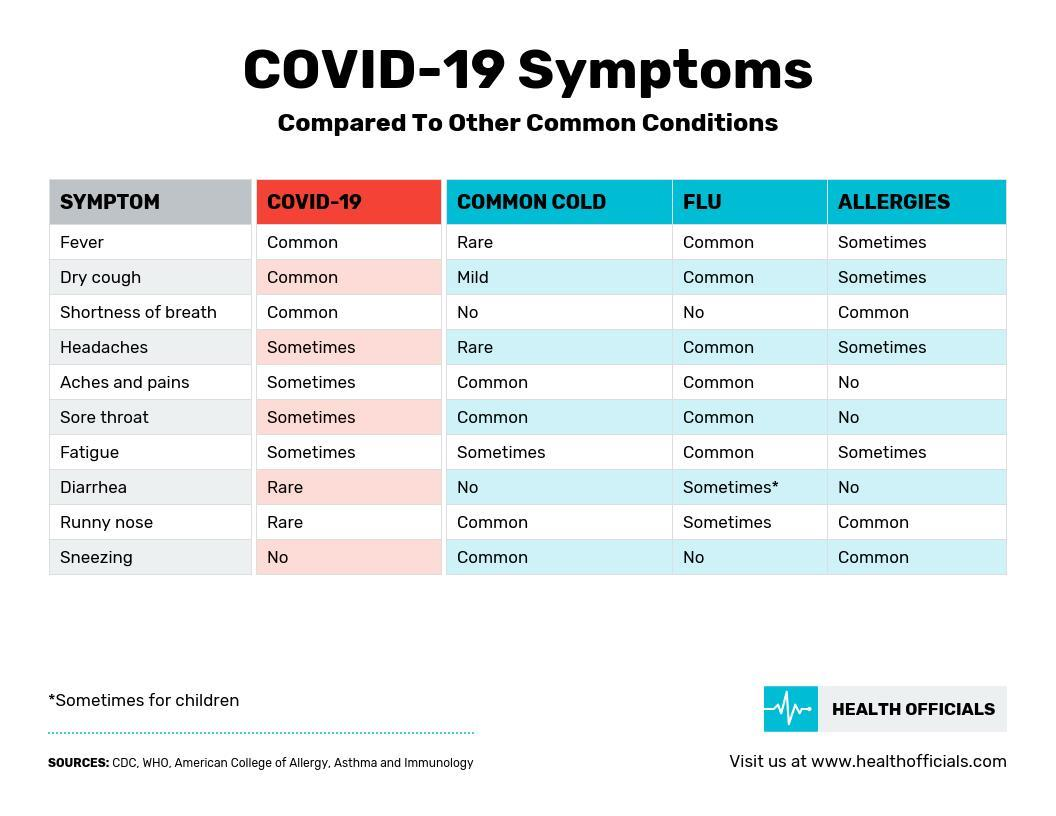Which are the rare symptoms of COVID-19?
Answer the question with a short phrase. Diarrhea, Runny nose Which is a never a symptom of both COVID-19 & flu? Sneezing Which symptom occur sometimes for both COVID-19 & common cold? Fatigue What are the common symptoms for both COVID-19 & Flu? Fever, Dry Cough Which are the rare symptoms of common cold? Fever, Headaches 